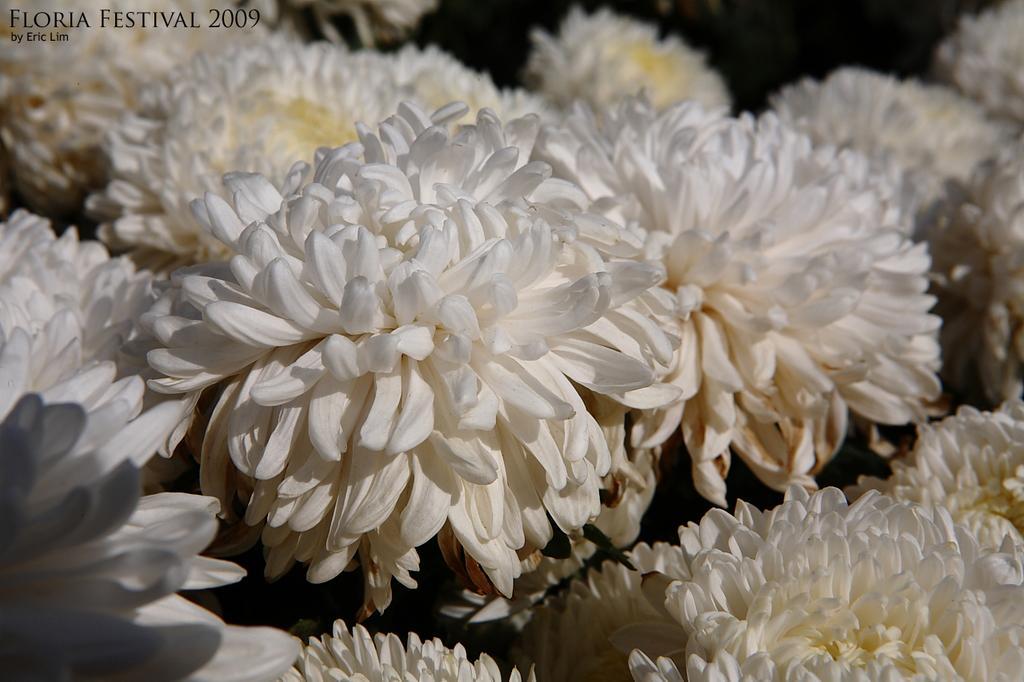In one or two sentences, can you explain what this image depicts? In this image we can some flowers which are in white color and we can see some text on the image. 